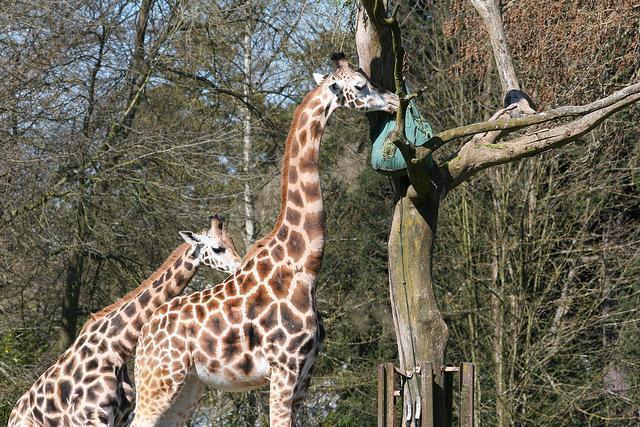What distinguishes the animals above from the rest?
Indicate the correct response by choosing from the four available options to answer the question.
Options: Shortest, fastest, tallest, browsers. Tallest. 